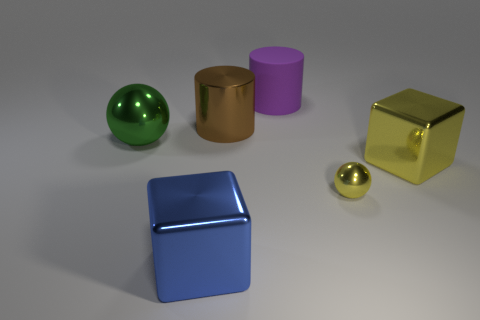How many other objects are the same color as the rubber cylinder?
Your answer should be very brief. 0. What is the material of the big thing right of the metal sphere in front of the green metallic object?
Offer a terse response. Metal. Are there any large yellow cubes?
Give a very brief answer. Yes. There is a shiny object that is on the left side of the cube to the left of the purple matte thing; how big is it?
Give a very brief answer. Large. Are there more things that are to the left of the large brown metallic cylinder than large metal cylinders that are in front of the green object?
Offer a terse response. Yes. What number of cylinders are either tiny yellow things or metal things?
Give a very brief answer. 1. Is there any other thing that is the same size as the blue object?
Your answer should be compact. Yes. Does the metal thing in front of the small yellow object have the same shape as the big brown object?
Give a very brief answer. No. What color is the tiny metal thing?
Make the answer very short. Yellow. The other object that is the same shape as the big purple matte thing is what color?
Your response must be concise. Brown. 